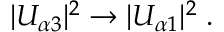Convert formula to latex. <formula><loc_0><loc_0><loc_500><loc_500>| U _ { \alpha 3 } | ^ { 2 } \to | U _ { \alpha 1 } | ^ { 2 } \, .</formula> 